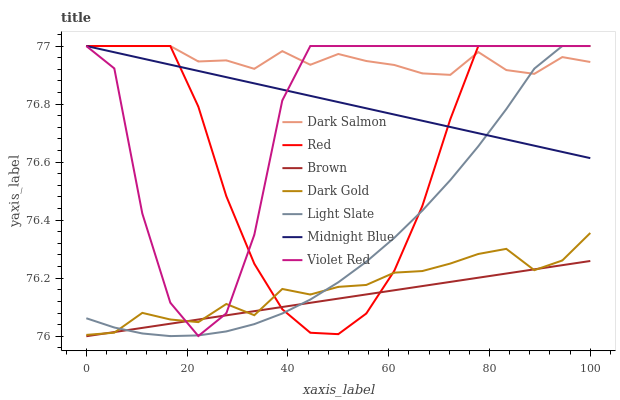Does Brown have the minimum area under the curve?
Answer yes or no. Yes. Does Dark Salmon have the maximum area under the curve?
Answer yes or no. Yes. Does Violet Red have the minimum area under the curve?
Answer yes or no. No. Does Violet Red have the maximum area under the curve?
Answer yes or no. No. Is Brown the smoothest?
Answer yes or no. Yes. Is Violet Red the roughest?
Answer yes or no. Yes. Is Midnight Blue the smoothest?
Answer yes or no. No. Is Midnight Blue the roughest?
Answer yes or no. No. Does Violet Red have the lowest value?
Answer yes or no. No. Does Red have the highest value?
Answer yes or no. Yes. Does Dark Gold have the highest value?
Answer yes or no. No. Is Dark Gold less than Midnight Blue?
Answer yes or no. Yes. Is Midnight Blue greater than Brown?
Answer yes or no. Yes. Does Dark Gold intersect Midnight Blue?
Answer yes or no. No. 